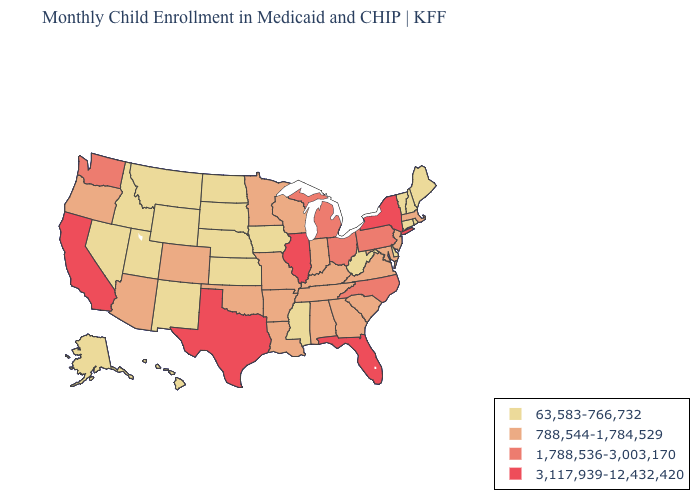Does New York have the highest value in the Northeast?
Quick response, please. Yes. Name the states that have a value in the range 788,544-1,784,529?
Give a very brief answer. Alabama, Arizona, Arkansas, Colorado, Georgia, Indiana, Kentucky, Louisiana, Maryland, Massachusetts, Minnesota, Missouri, New Jersey, Oklahoma, Oregon, South Carolina, Tennessee, Virginia, Wisconsin. Name the states that have a value in the range 3,117,939-12,432,420?
Quick response, please. California, Florida, Illinois, New York, Texas. Which states have the lowest value in the USA?
Concise answer only. Alaska, Connecticut, Delaware, Hawaii, Idaho, Iowa, Kansas, Maine, Mississippi, Montana, Nebraska, Nevada, New Hampshire, New Mexico, North Dakota, Rhode Island, South Dakota, Utah, Vermont, West Virginia, Wyoming. Name the states that have a value in the range 1,788,536-3,003,170?
Short answer required. Michigan, North Carolina, Ohio, Pennsylvania, Washington. Name the states that have a value in the range 3,117,939-12,432,420?
Keep it brief. California, Florida, Illinois, New York, Texas. Does Missouri have the highest value in the MidWest?
Be succinct. No. What is the value of Wyoming?
Quick response, please. 63,583-766,732. Among the states that border Connecticut , which have the lowest value?
Give a very brief answer. Rhode Island. Does Maine have a higher value than Rhode Island?
Quick response, please. No. What is the value of Louisiana?
Short answer required. 788,544-1,784,529. Does California have the highest value in the USA?
Answer briefly. Yes. Which states hav the highest value in the MidWest?
Keep it brief. Illinois. Among the states that border Texas , does New Mexico have the highest value?
Be succinct. No. What is the value of North Carolina?
Keep it brief. 1,788,536-3,003,170. 